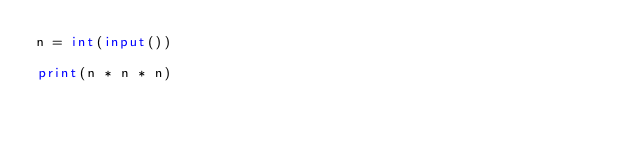Convert code to text. <code><loc_0><loc_0><loc_500><loc_500><_Python_>n = int(input())

print(n * n * n)</code> 